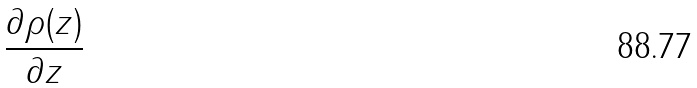<formula> <loc_0><loc_0><loc_500><loc_500>\frac { \partial \rho ( z ) } { \partial z }</formula> 